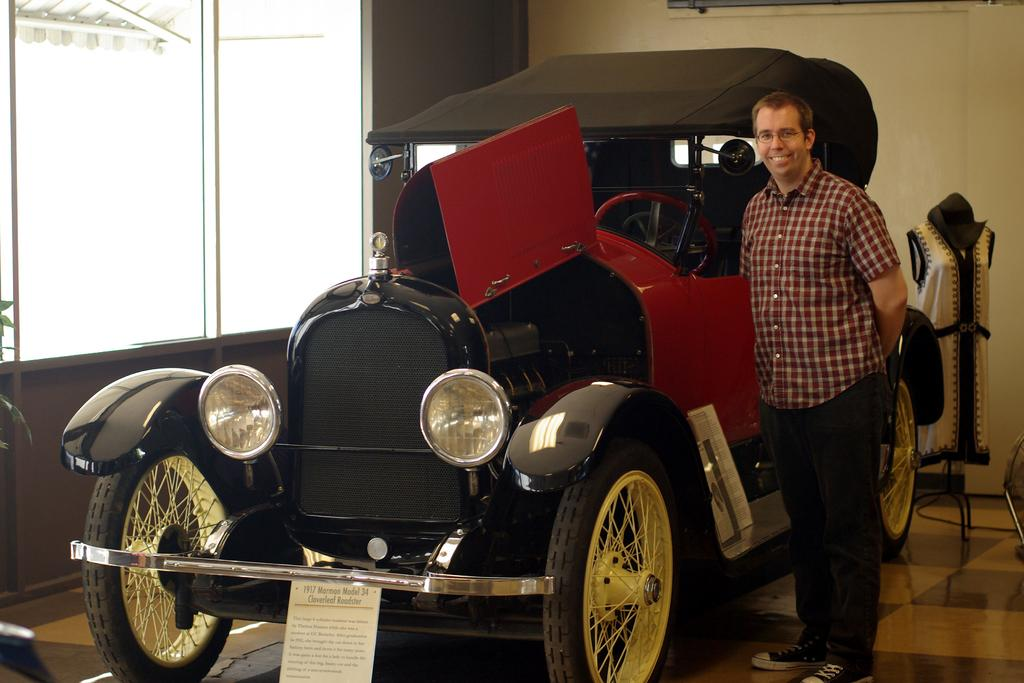What is the man in the image doing? The man is standing and smiling in the image. What can be seen on the floor in the image? There is a vehicle on the floor in the image. What is visible in the background of the image? There is a wall, a mannequin with cloth, and a window in the background of the image. How many steps can be seen in the image? There are no steps visible in the image. 